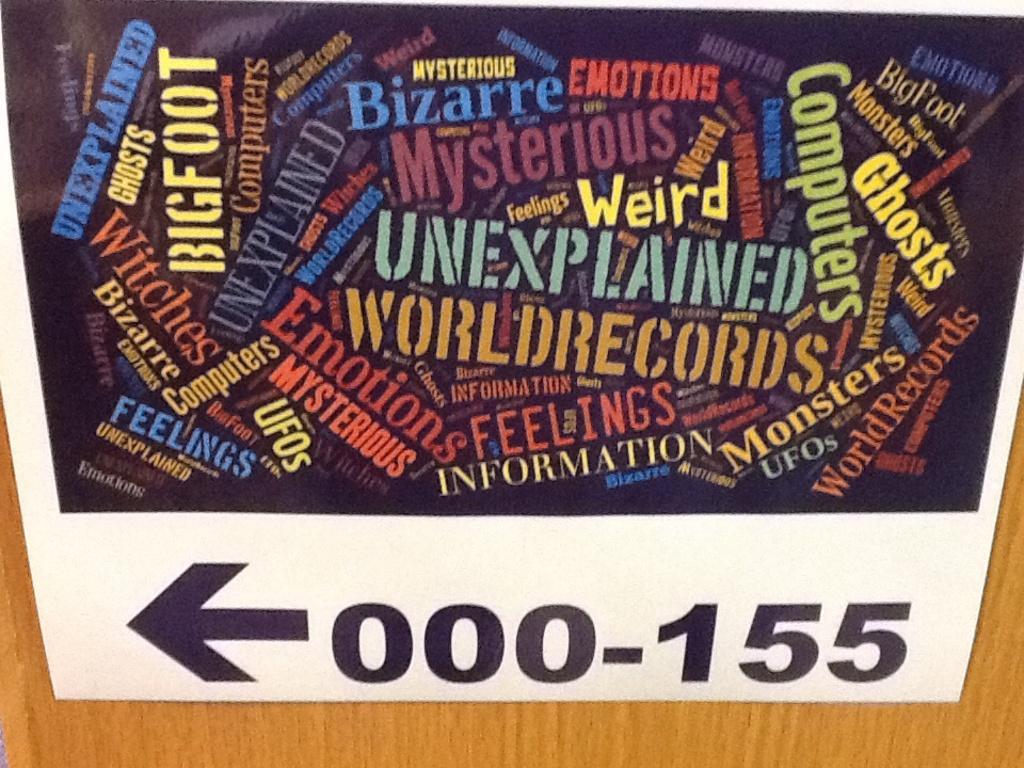What is one of the adjectives mentioned on the sign?
Your response must be concise. Weird. What are the numbers?
Your answer should be compact. 000-155. 